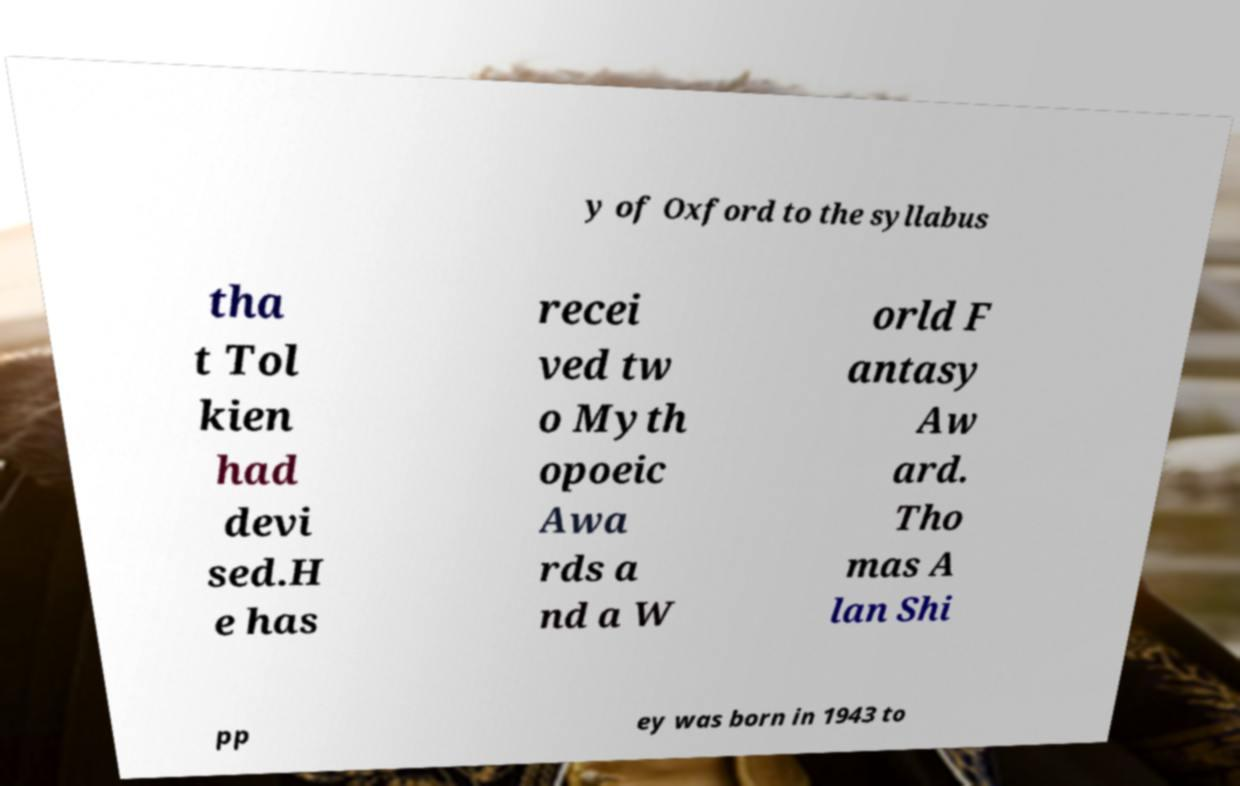Can you accurately transcribe the text from the provided image for me? y of Oxford to the syllabus tha t Tol kien had devi sed.H e has recei ved tw o Myth opoeic Awa rds a nd a W orld F antasy Aw ard. Tho mas A lan Shi pp ey was born in 1943 to 